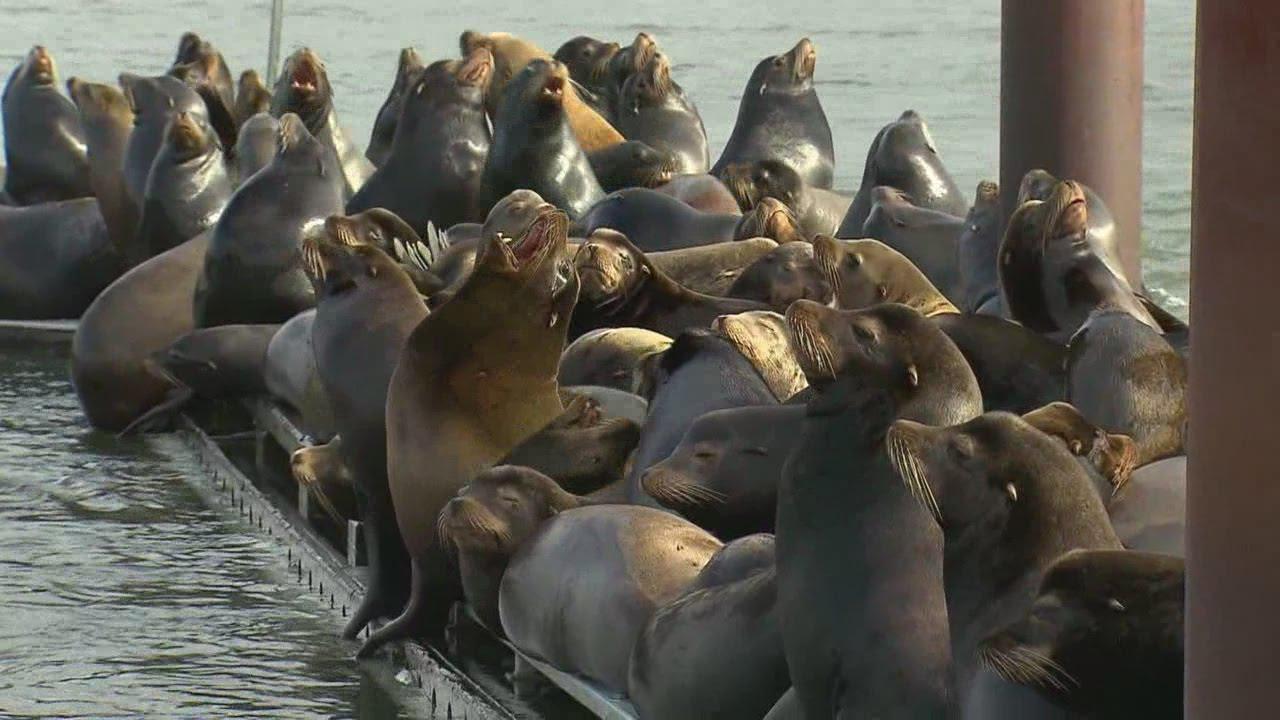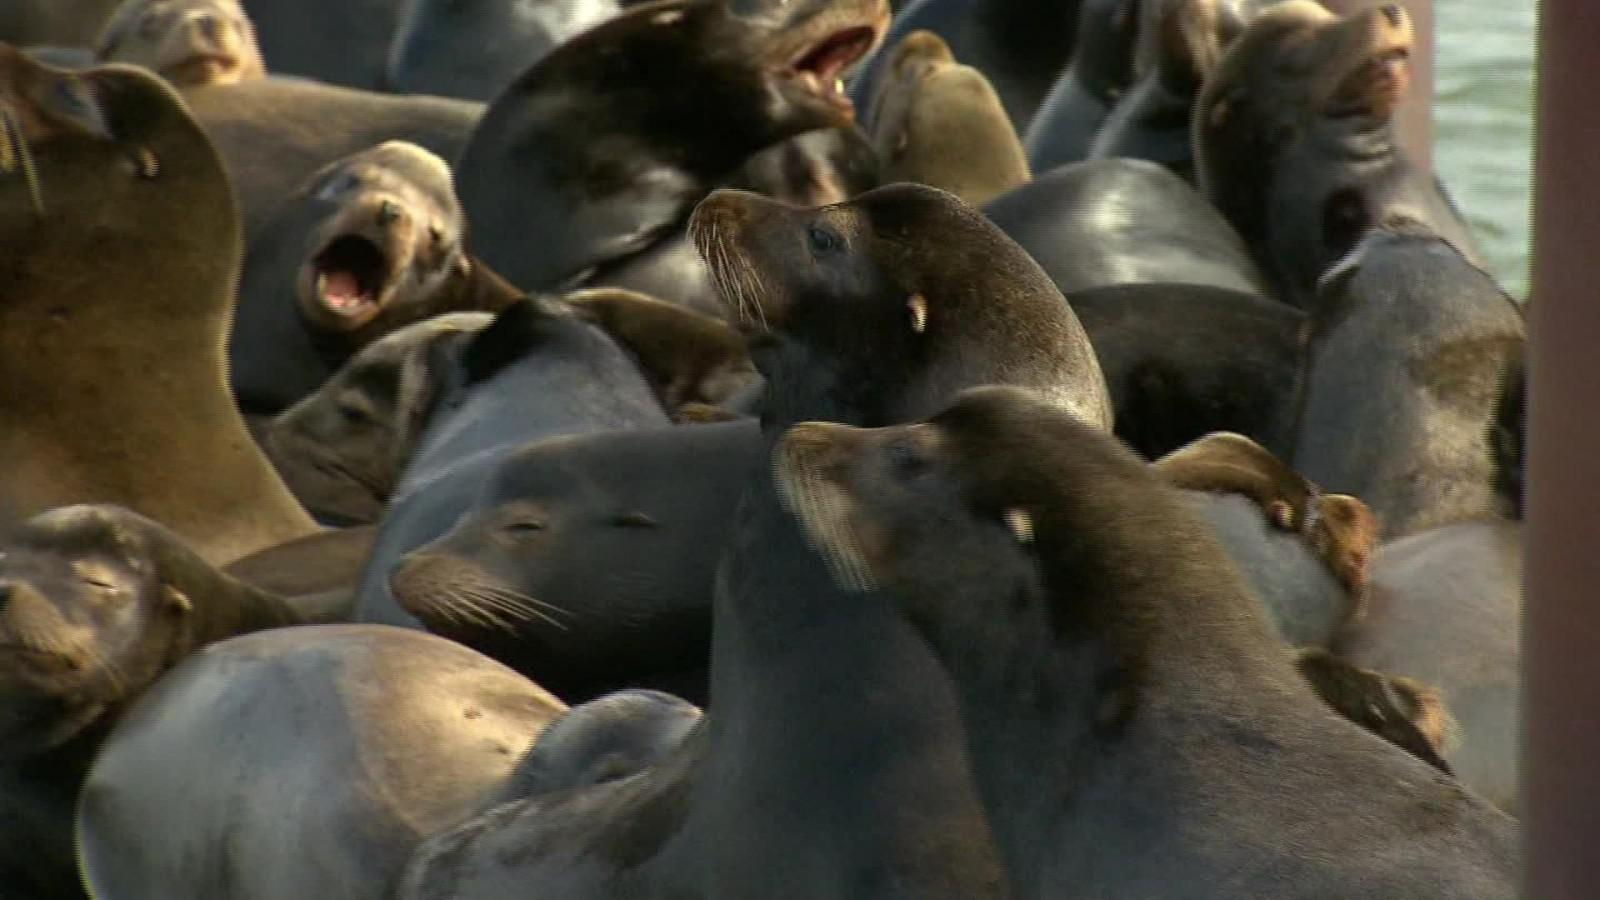The first image is the image on the left, the second image is the image on the right. For the images displayed, is the sentence "In at least one of the images, there are visible holes in the edges of the floating dock." factually correct? Answer yes or no. Yes. The first image is the image on the left, the second image is the image on the right. Analyze the images presented: Is the assertion "Each image shows a mass of seals on a platform with brown vertical columns." valid? Answer yes or no. Yes. 